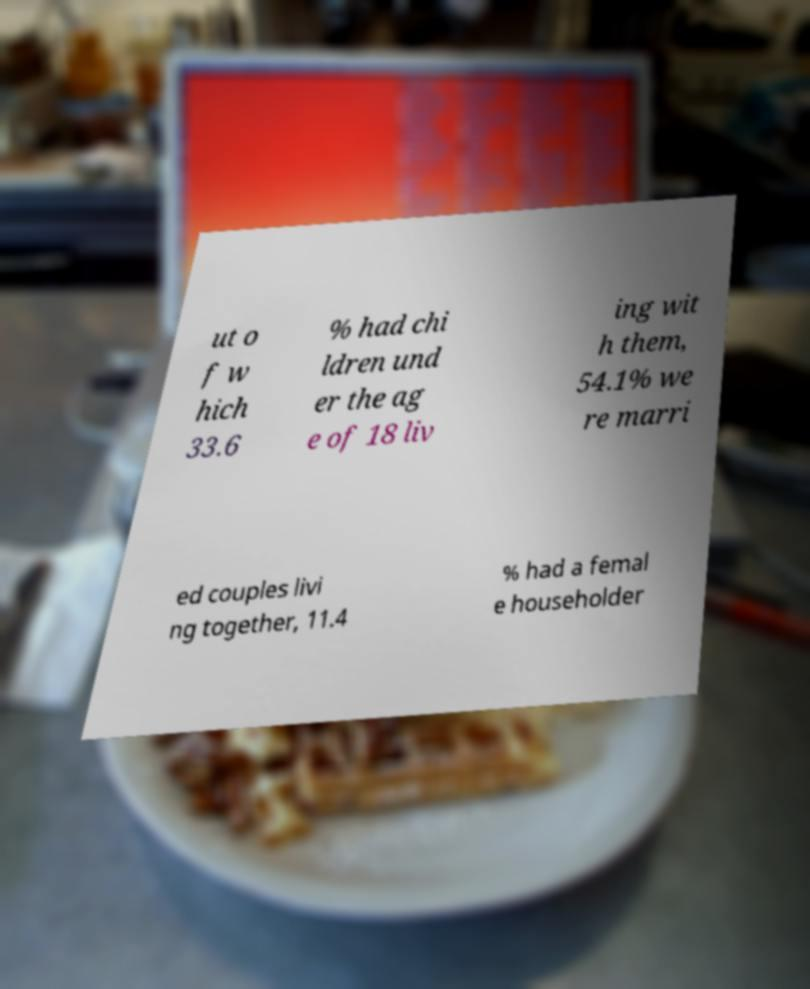Can you read and provide the text displayed in the image?This photo seems to have some interesting text. Can you extract and type it out for me? ut o f w hich 33.6 % had chi ldren und er the ag e of 18 liv ing wit h them, 54.1% we re marri ed couples livi ng together, 11.4 % had a femal e householder 